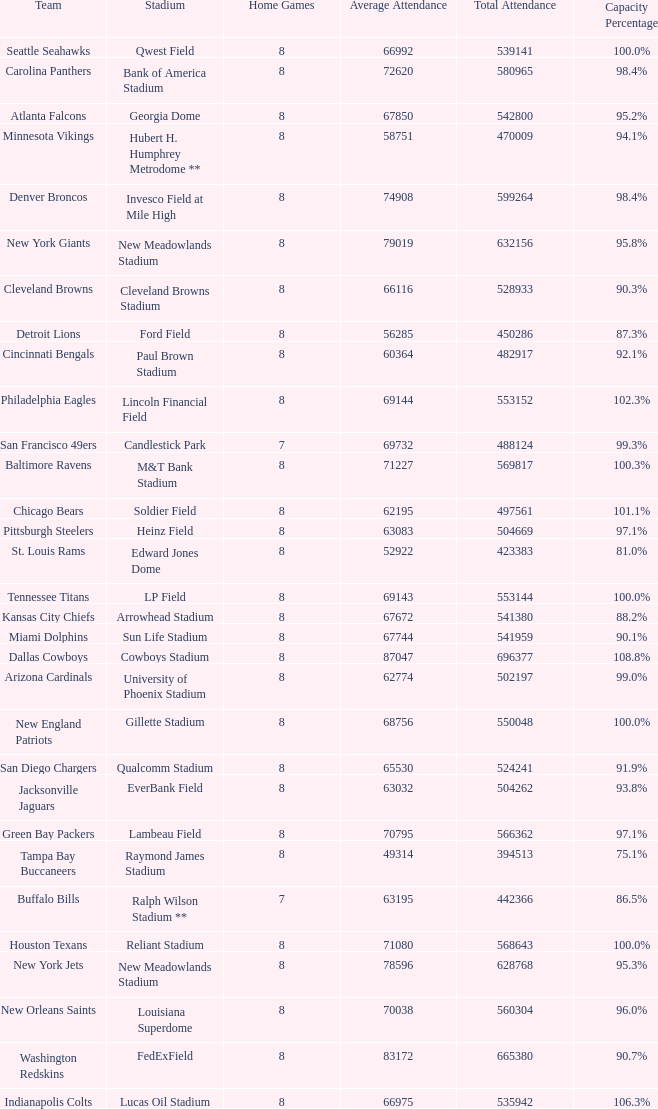What was the capacity for the Denver Broncos? 98.4%. 